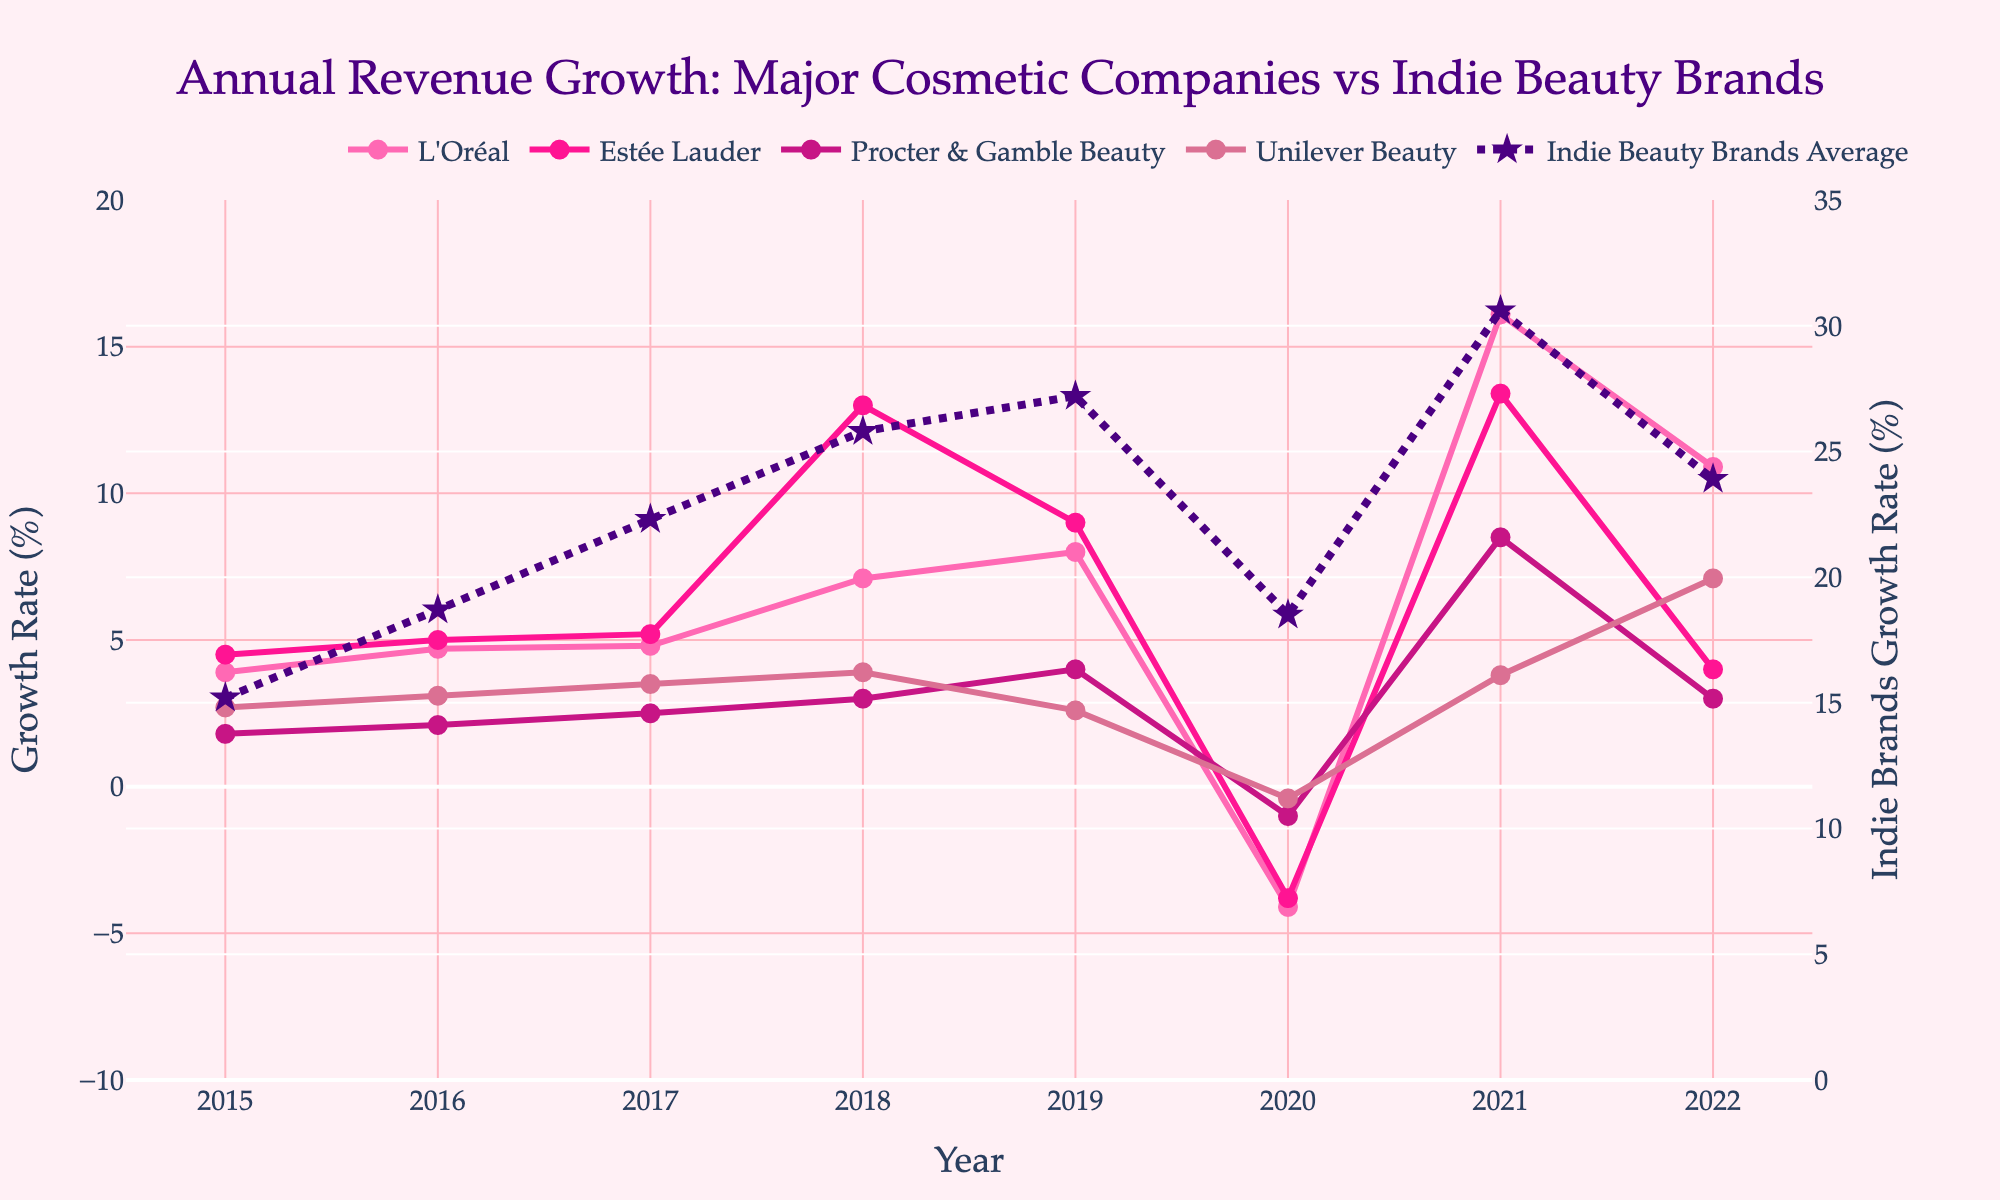What year did L'Oréal experience the highest revenue growth? By examining the line corresponding to L'Oréal, we find that the highest point is in 2021 with a growth rate of 16.1%.
Answer: 2021 How does the revenue growth of Estée Lauder in 2018 compare to that of Procter & Gamble Beauty in the same year? Estée Lauder's growth rate in 2018 is 13.0%, while Procter & Gamble Beauty has a growth rate of 3.0%. Therefore, Estée Lauder's growth rate is higher than that of Procter & Gamble Beauty in 2018.
Answer: Estée Lauder's growth rate is higher What was the average revenue growth of Unilever Beauty from 2015 to 2022? To calculate the average, sum the revenue growth values for Unilever Beauty from 2015 to 2022 and then divide by the number of years. Sum = 2.7 + 3.1 + 3.5 + 3.9 + 2.6 - 0.4 + 3.8 + 7.1 = 26.3; Average = 26.3 / 8 = 3.29.
Answer: 3.29% Considering only 2019, which company had the lowest revenue growth rate? By comparing the growth rates of all companies in 2019, Procter & Gamble Beauty had the lowest growth at 4.0%.
Answer: Procter & Gamble Beauty In 2020, which company showed a positive revenue growth rate? By examining the data in 2020, none of the major brands show a positive growth rate. However, the Indie Beauty Brands Average has a growth rate of 18.5%.
Answer: Indie Beauty Brands Average Calculate the total revenue growth for Procter & Gamble Beauty from 2016 to 2019. Sum the growth rates for Procter & Gamble Beauty from 2016 to 2019: 2.1 + 2.5 + 3.0 + 4.0 = 11.6.
Answer: 11.6% Which year shows a negative revenue growth for all the major companies except Indie Beauty? By examining the data, the year 2020 shows negative growth rates for L'Oréal (-4.1%), Estée Lauder (-3.8%), Procter & Gamble Beauty (-1.0%), and Unilever Beauty (-0.4%), while Indie Beauty Brands Average has positive growth.
Answer: 2020 Does Indie Beauty Brands Average growth ever fall below 20% from 2015 to 2022? By examining the line of Indie Beauty Brands Average, the values fall below 20% in only two years: 2015 and 2020.
Answer: Yes Compare the revenue growth of Indie Beauty Brands to Unilever Beauty in 2022. Indie Beauty Brands Average growth rate in 2022 is 23.9%, while Unilever Beauty's growth rate is 7.1%. Therefore, Indie Beauty Brands have a higher growth rate.
Answer: Indie Beauty Brands have a higher growth rate Between L'Oréal and Estée Lauder, which company had more consistent revenue growth from 2015 to 2022? Looking at the lines representing L'Oréal and Estée Lauder, L'Oréal's line is smoother with minor variations, whereas Estée Lauder's has a large spike in 2018 and multiple changes. Therefore, L'Oréal has more consistent revenue growth.
Answer: L'Oréal 